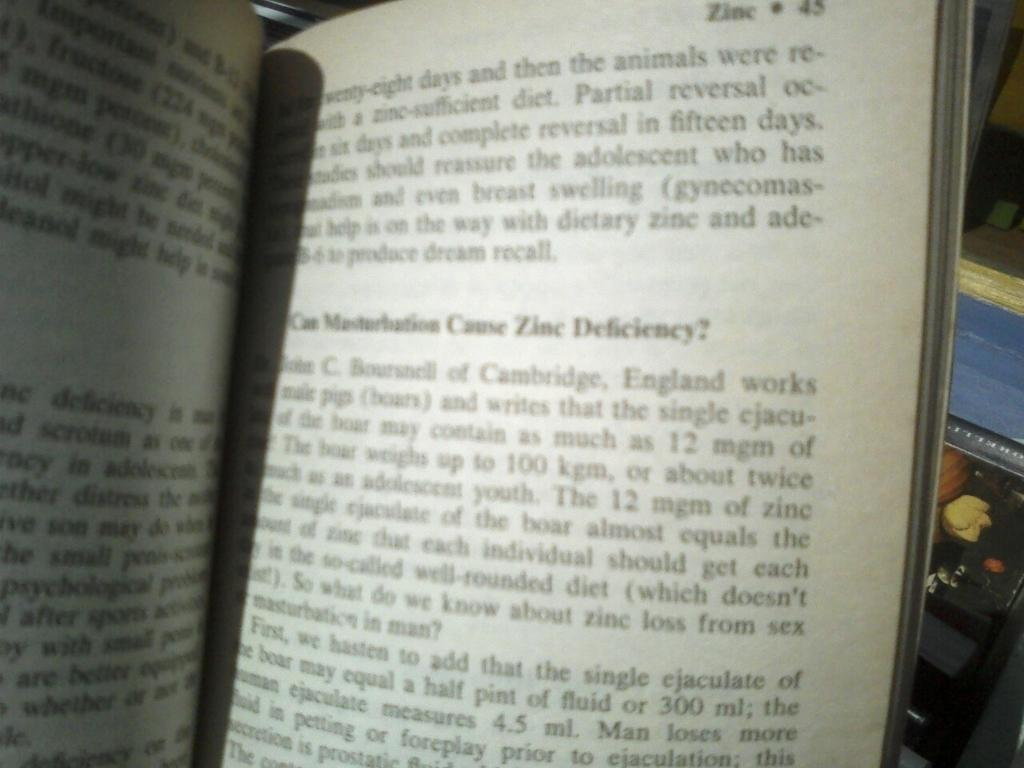<image>
Give a short and clear explanation of the subsequent image. Book that is about the mineral Zinc and is set on page 45. 